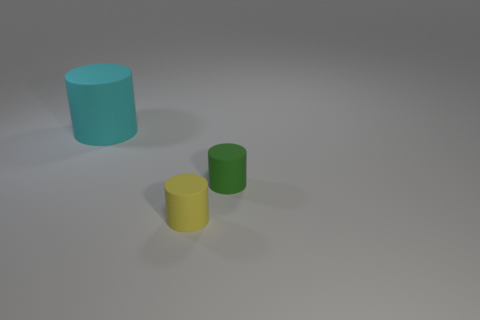Looking at the colors of the objects, what can you infer about the lighting in the scene? The lighting in the scene seems to be soft and diffused, as evidenced by the soft shadows cast by the objects and the lack of harsh highlights. This allows the true colors of the objects—cyan, green, and yellow—to present themselves clearly without significant color distortion from strong light sources. 